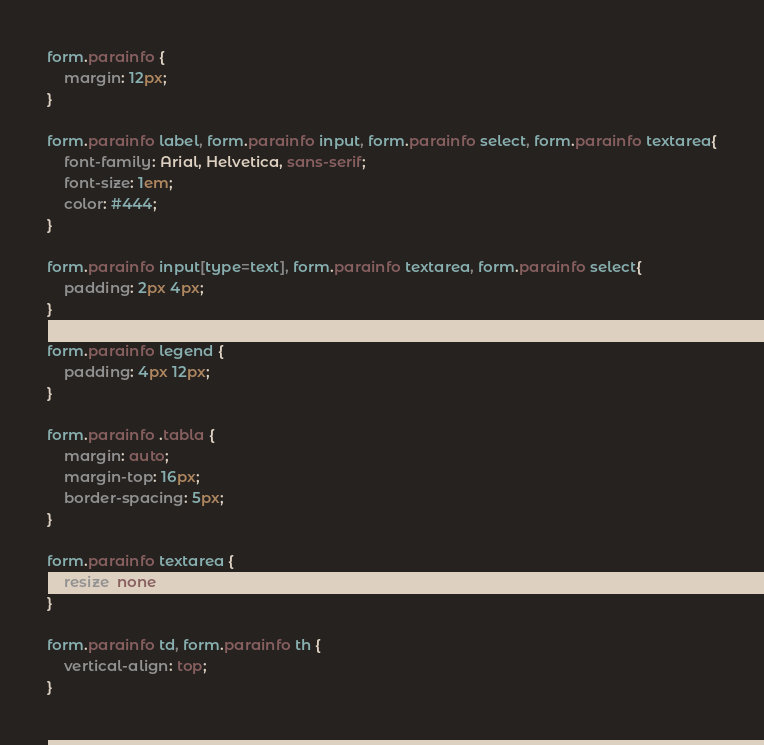<code> <loc_0><loc_0><loc_500><loc_500><_CSS_>form.parainfo {
    margin: 12px;
}

form.parainfo label, form.parainfo input, form.parainfo select, form.parainfo textarea{
    font-family: Arial, Helvetica, sans-serif;
    font-size: 1em;
    color: #444;
}

form.parainfo input[type=text], form.parainfo textarea, form.parainfo select{
    padding: 2px 4px;
}
            
form.parainfo legend {
    padding: 4px 12px;
}

form.parainfo .tabla {
    margin: auto;
    margin-top: 16px;
    border-spacing: 5px;
}

form.parainfo textarea {
    resize: none;
}

form.parainfo td, form.parainfo th {
    vertical-align: top;
}</code> 